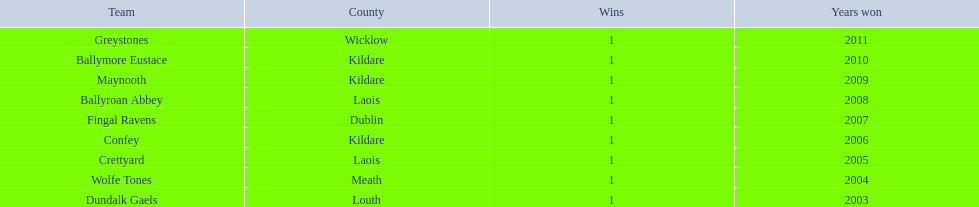What county is the team that won in 2009 from? Kildare. What is the teams name? Maynooth. 